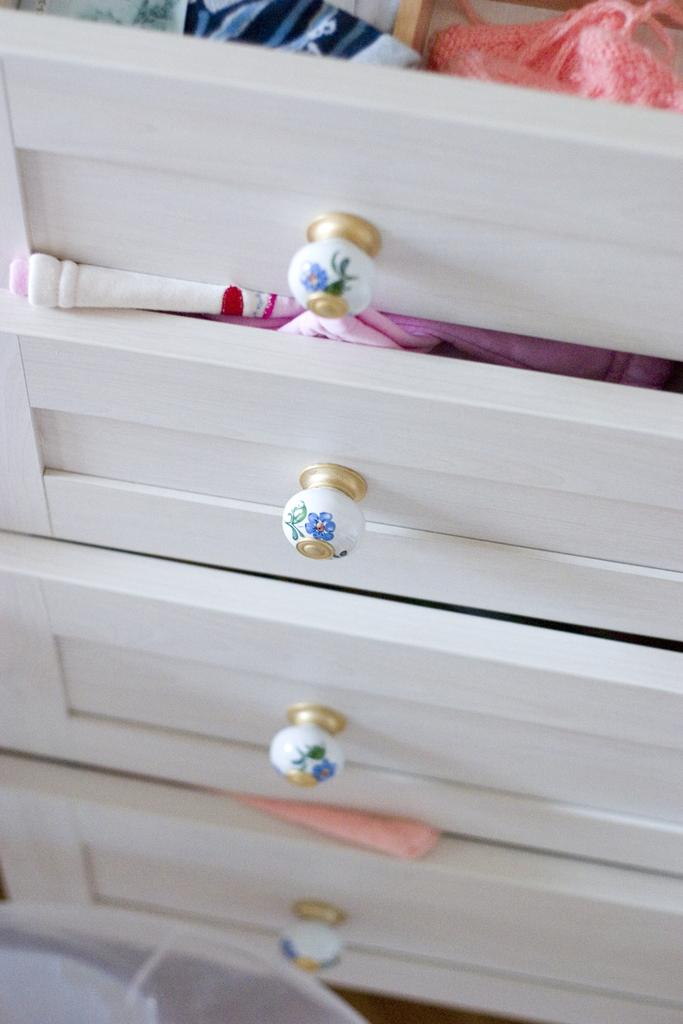What type of furniture is present in the image? There is a cupboard in the image. What feature does the cupboard have? The cupboard has drawers. What items can be found inside the cupboard? There are clothes in the drawers. What type of mint can be seen growing in the image? There is no mint plant present in the image. How does the cupboard improve digestion in the image? The cupboard does not have any direct impact on digestion; it is a piece of furniture used for storage. 